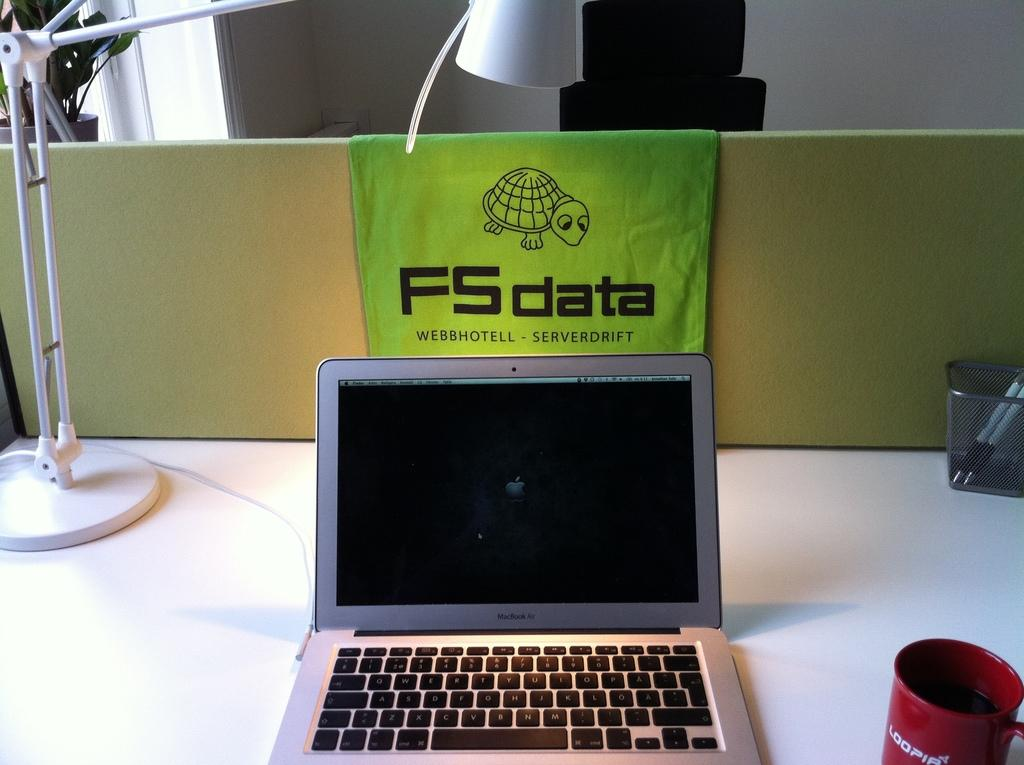<image>
Describe the image concisely. the letters FS are on a green cloth 